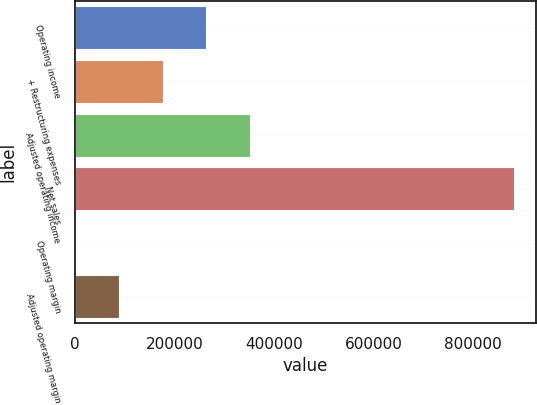Convert chart to OTSL. <chart><loc_0><loc_0><loc_500><loc_500><bar_chart><fcel>Operating income<fcel>+ Restructuring expenses<fcel>Adjusted operating income<fcel>Net sales<fcel>Operating margin<fcel>Adjusted operating margin<nl><fcel>264306<fcel>176213<fcel>352399<fcel>880957<fcel>27.4<fcel>88120.4<nl></chart> 